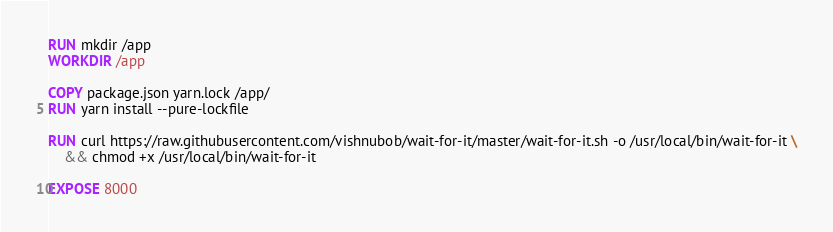Convert code to text. <code><loc_0><loc_0><loc_500><loc_500><_Dockerfile_>
RUN mkdir /app
WORKDIR /app

COPY package.json yarn.lock /app/
RUN yarn install --pure-lockfile

RUN curl https://raw.githubusercontent.com/vishnubob/wait-for-it/master/wait-for-it.sh -o /usr/local/bin/wait-for-it \
    && chmod +x /usr/local/bin/wait-for-it

EXPOSE 8000
</code> 